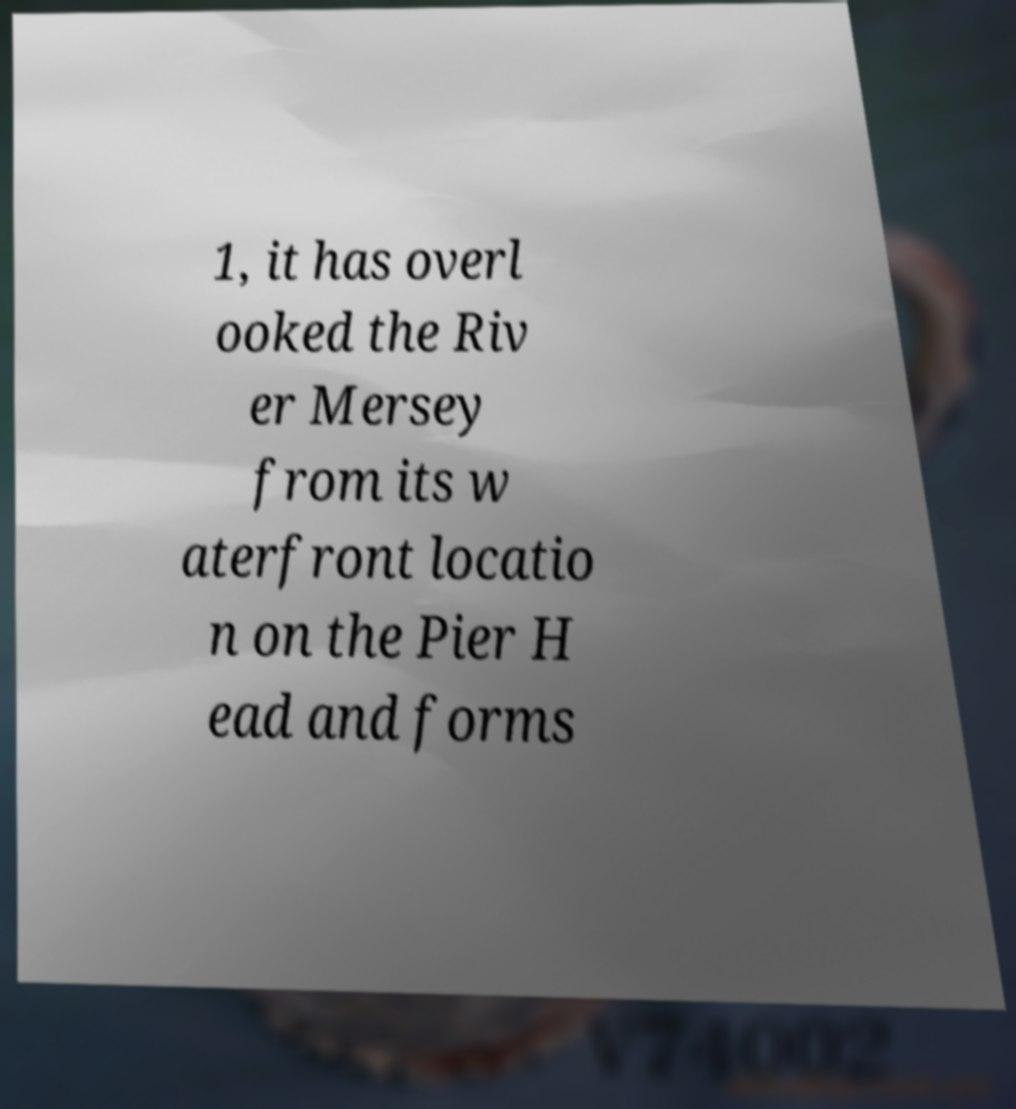I need the written content from this picture converted into text. Can you do that? 1, it has overl ooked the Riv er Mersey from its w aterfront locatio n on the Pier H ead and forms 